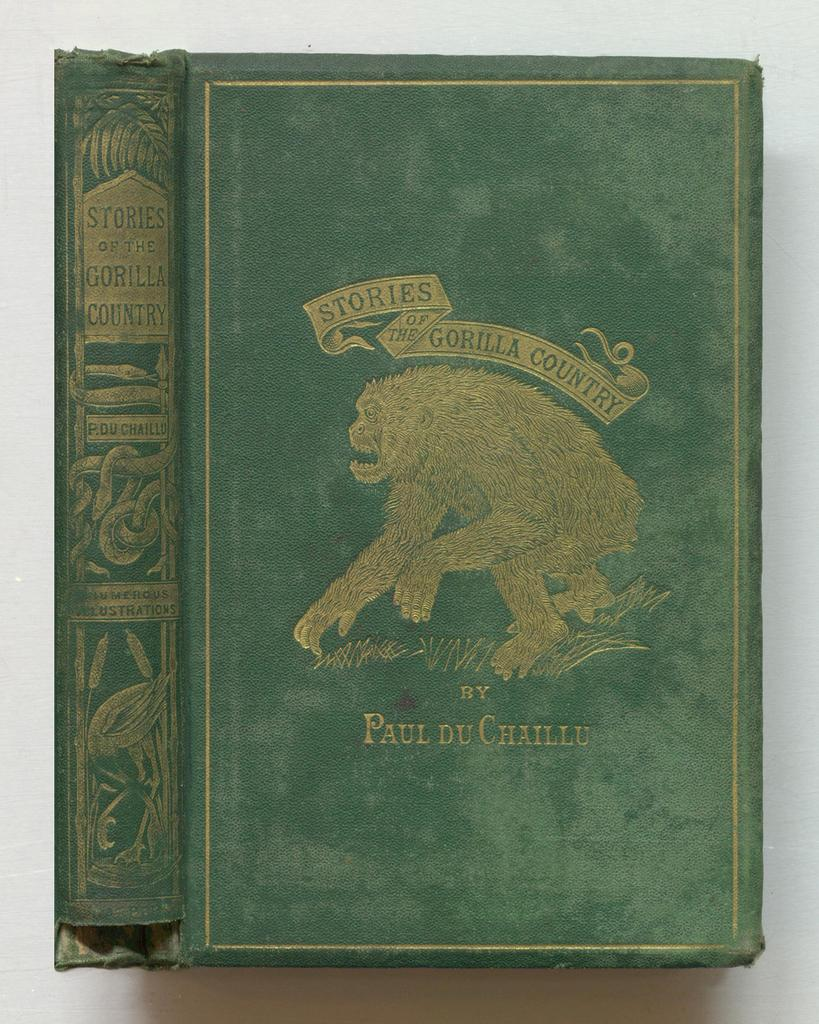<image>
Create a compact narrative representing the image presented. a gren book that is about stories of Gorilla Country 